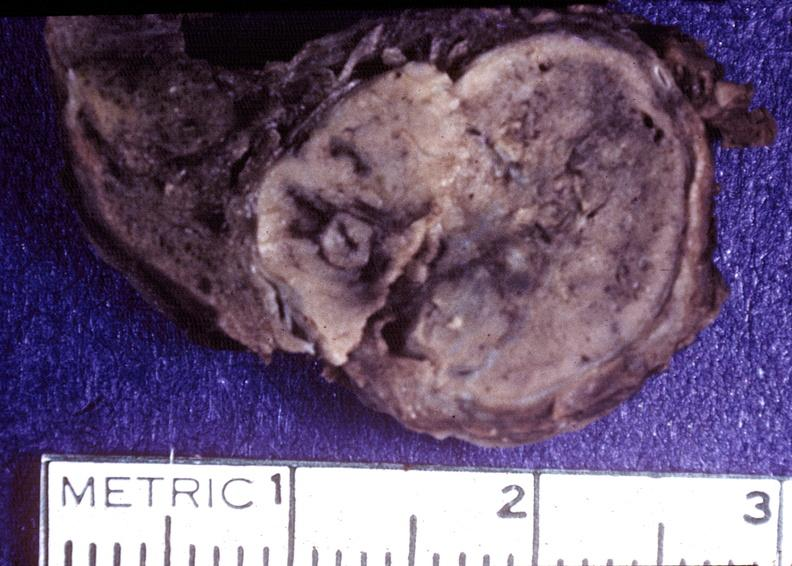where does this belong to?
Answer the question using a single word or phrase. Endocrine system 